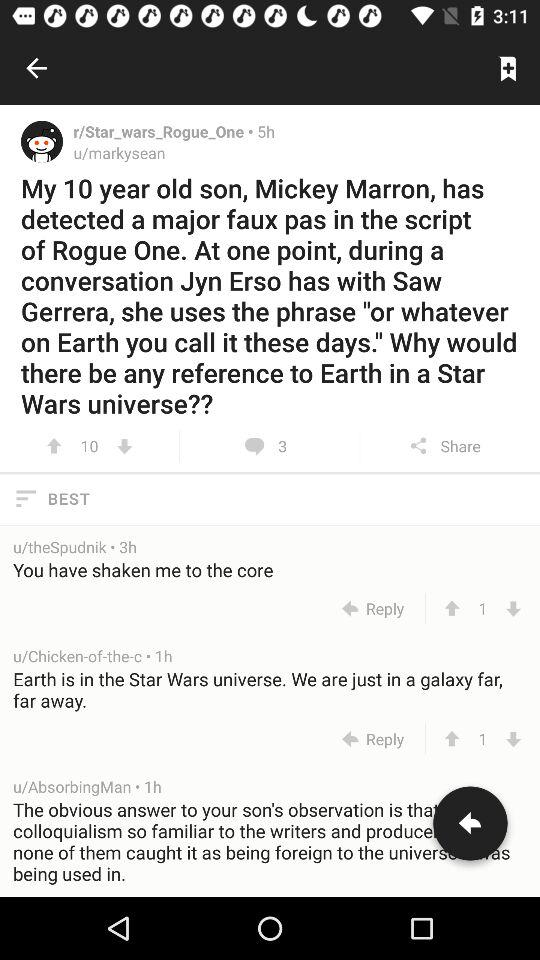How many comments are there? There are 3 comments. 